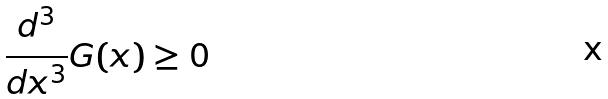Convert formula to latex. <formula><loc_0><loc_0><loc_500><loc_500>\frac { d ^ { 3 } } { d x ^ { 3 } } G ( x ) \geq 0</formula> 